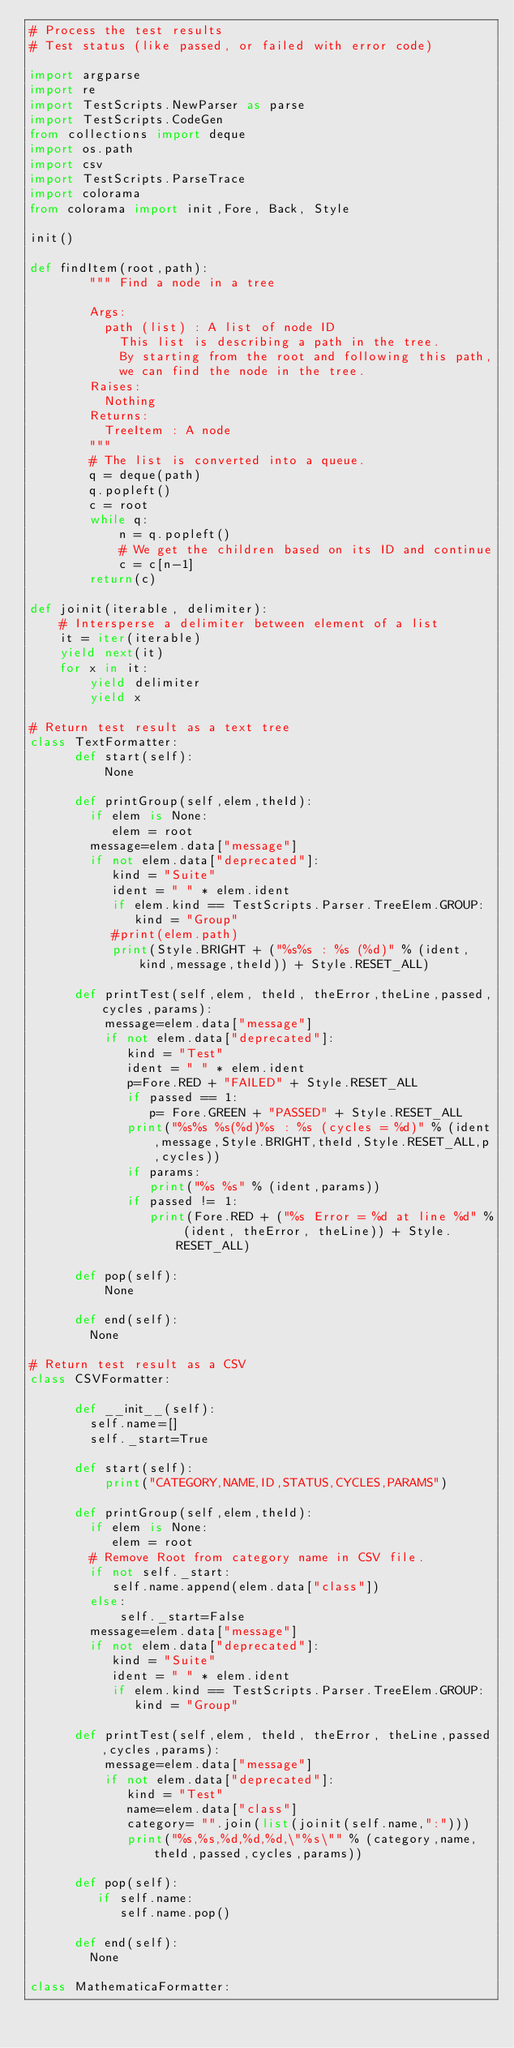<code> <loc_0><loc_0><loc_500><loc_500><_Python_># Process the test results
# Test status (like passed, or failed with error code)

import argparse
import re 
import TestScripts.NewParser as parse
import TestScripts.CodeGen
from collections import deque
import os.path
import csv
import TestScripts.ParseTrace
import colorama
from colorama import init,Fore, Back, Style

init()

def findItem(root,path):
        """ Find a node in a tree
      
        Args:
          path (list) : A list of node ID
            This list is describing a path in the tree.
            By starting from the root and following this path,
            we can find the node in the tree.
        Raises:
          Nothing 
        Returns:
          TreeItem : A node
        """
        # The list is converted into a queue.
        q = deque(path) 
        q.popleft()
        c = root
        while q:
            n = q.popleft() 
            # We get the children based on its ID and continue
            c = c[n-1]
        return(c)

def joinit(iterable, delimiter):
    # Intersperse a delimiter between element of a list
    it = iter(iterable)
    yield next(it)
    for x in it:
        yield delimiter
        yield x

# Return test result as a text tree
class TextFormatter:
      def start(self):
          None 

      def printGroup(self,elem,theId):
        if elem is None:
           elem = root
        message=elem.data["message"]
        if not elem.data["deprecated"]:
           kind = "Suite"
           ident = " " * elem.ident
           if elem.kind == TestScripts.Parser.TreeElem.GROUP:
              kind = "Group"
           #print(elem.path)
           print(Style.BRIGHT + ("%s%s : %s (%d)" % (ident,kind,message,theId)) + Style.RESET_ALL)

      def printTest(self,elem, theId, theError,theLine,passed,cycles,params):
          message=elem.data["message"]
          if not elem.data["deprecated"]:
             kind = "Test"
             ident = " " * elem.ident
             p=Fore.RED + "FAILED" + Style.RESET_ALL
             if passed == 1:
                p= Fore.GREEN + "PASSED" + Style.RESET_ALL
             print("%s%s %s(%d)%s : %s (cycles = %d)" % (ident,message,Style.BRIGHT,theId,Style.RESET_ALL,p,cycles))
             if params:
                print("%s %s" % (ident,params))
             if passed != 1:
                print(Fore.RED + ("%s Error = %d at line %d" % (ident, theError, theLine)) + Style.RESET_ALL)

      def pop(self):
          None

      def end(self):
        None

# Return test result as a CSV
class CSVFormatter:

      def __init__(self):
        self.name=[]
        self._start=True

      def start(self):
          print("CATEGORY,NAME,ID,STATUS,CYCLES,PARAMS") 
          
      def printGroup(self,elem,theId):
        if elem is None:
           elem = root
        # Remove Root from category name in CSV file.
        if not self._start:
           self.name.append(elem.data["class"])
        else:
            self._start=False
        message=elem.data["message"]
        if not elem.data["deprecated"]:
           kind = "Suite"
           ident = " " * elem.ident
           if elem.kind == TestScripts.Parser.TreeElem.GROUP:
              kind = "Group"

      def printTest(self,elem, theId, theError, theLine,passed,cycles,params):
          message=elem.data["message"]
          if not elem.data["deprecated"]:
             kind = "Test"
             name=elem.data["class"] 
             category= "".join(list(joinit(self.name,":")))
             print("%s,%s,%d,%d,%d,\"%s\"" % (category,name,theId,passed,cycles,params))

      def pop(self):
         if self.name:
            self.name.pop()

      def end(self):
        None

class MathematicaFormatter:
</code> 